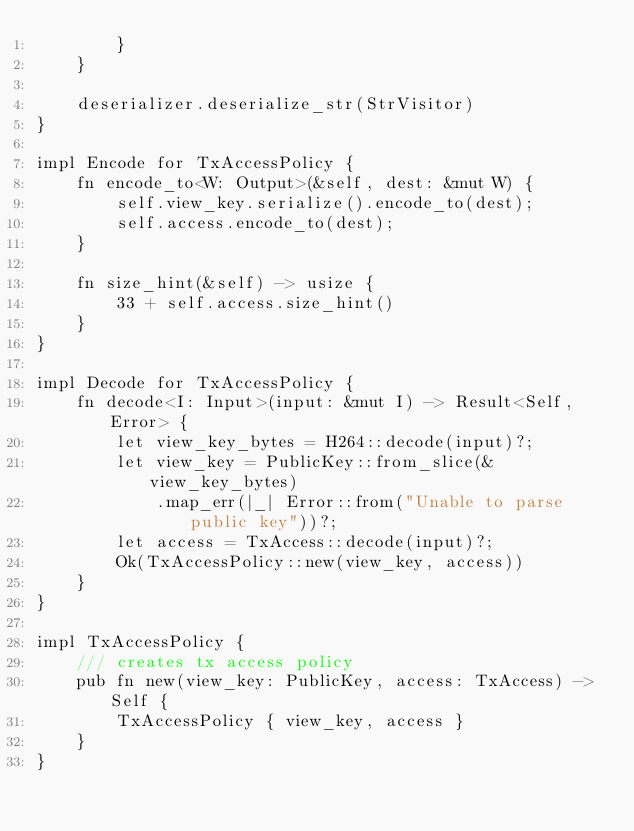Convert code to text. <code><loc_0><loc_0><loc_500><loc_500><_Rust_>        }
    }

    deserializer.deserialize_str(StrVisitor)
}

impl Encode for TxAccessPolicy {
    fn encode_to<W: Output>(&self, dest: &mut W) {
        self.view_key.serialize().encode_to(dest);
        self.access.encode_to(dest);
    }

    fn size_hint(&self) -> usize {
        33 + self.access.size_hint()
    }
}

impl Decode for TxAccessPolicy {
    fn decode<I: Input>(input: &mut I) -> Result<Self, Error> {
        let view_key_bytes = H264::decode(input)?;
        let view_key = PublicKey::from_slice(&view_key_bytes)
            .map_err(|_| Error::from("Unable to parse public key"))?;
        let access = TxAccess::decode(input)?;
        Ok(TxAccessPolicy::new(view_key, access))
    }
}

impl TxAccessPolicy {
    /// creates tx access policy
    pub fn new(view_key: PublicKey, access: TxAccess) -> Self {
        TxAccessPolicy { view_key, access }
    }
}
</code> 